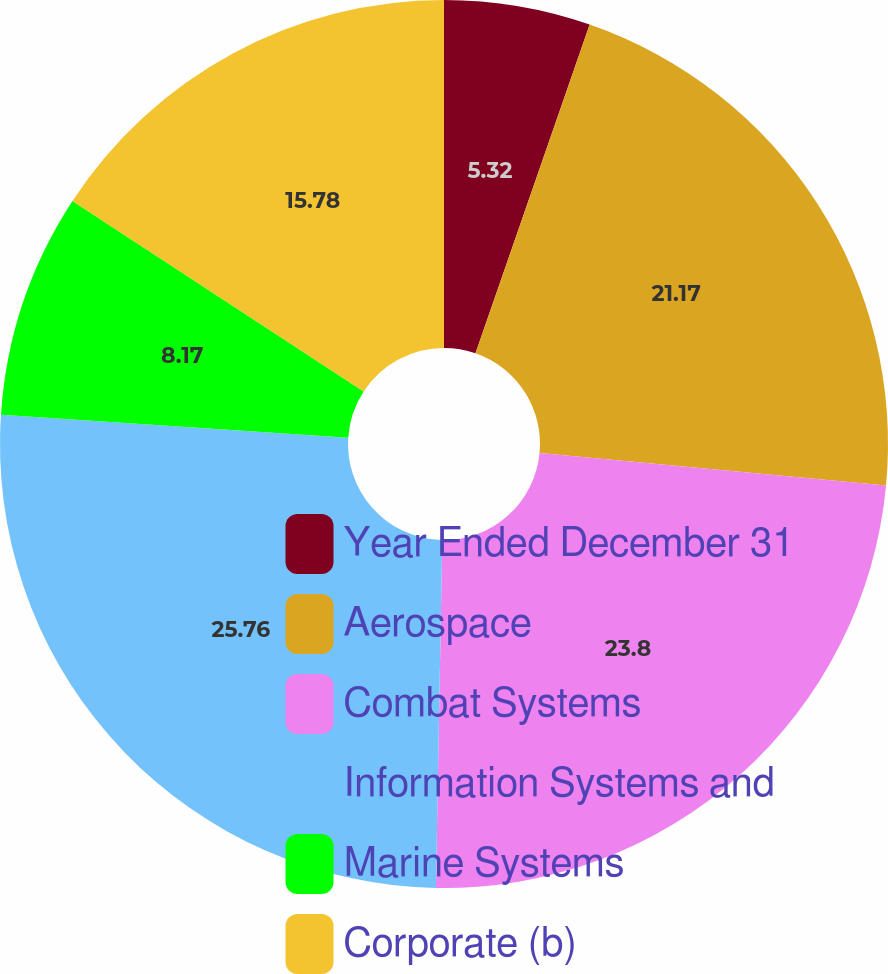Convert chart. <chart><loc_0><loc_0><loc_500><loc_500><pie_chart><fcel>Year Ended December 31<fcel>Aerospace<fcel>Combat Systems<fcel>Information Systems and<fcel>Marine Systems<fcel>Corporate (b)<nl><fcel>5.32%<fcel>21.17%<fcel>23.8%<fcel>25.76%<fcel>8.17%<fcel>15.78%<nl></chart> 